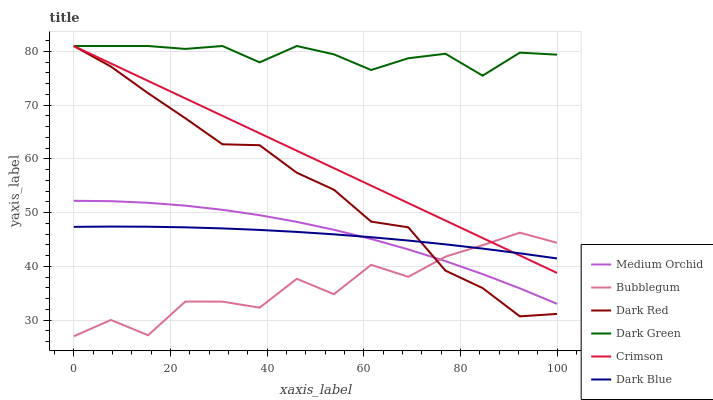Does Bubblegum have the minimum area under the curve?
Answer yes or no. Yes. Does Dark Green have the maximum area under the curve?
Answer yes or no. Yes. Does Medium Orchid have the minimum area under the curve?
Answer yes or no. No. Does Medium Orchid have the maximum area under the curve?
Answer yes or no. No. Is Crimson the smoothest?
Answer yes or no. Yes. Is Bubblegum the roughest?
Answer yes or no. Yes. Is Medium Orchid the smoothest?
Answer yes or no. No. Is Medium Orchid the roughest?
Answer yes or no. No. Does Medium Orchid have the lowest value?
Answer yes or no. No. Does Dark Green have the highest value?
Answer yes or no. Yes. Does Medium Orchid have the highest value?
Answer yes or no. No. Is Dark Blue less than Dark Green?
Answer yes or no. Yes. Is Crimson greater than Medium Orchid?
Answer yes or no. Yes. Does Crimson intersect Dark Green?
Answer yes or no. Yes. Is Crimson less than Dark Green?
Answer yes or no. No. Is Crimson greater than Dark Green?
Answer yes or no. No. Does Dark Blue intersect Dark Green?
Answer yes or no. No. 